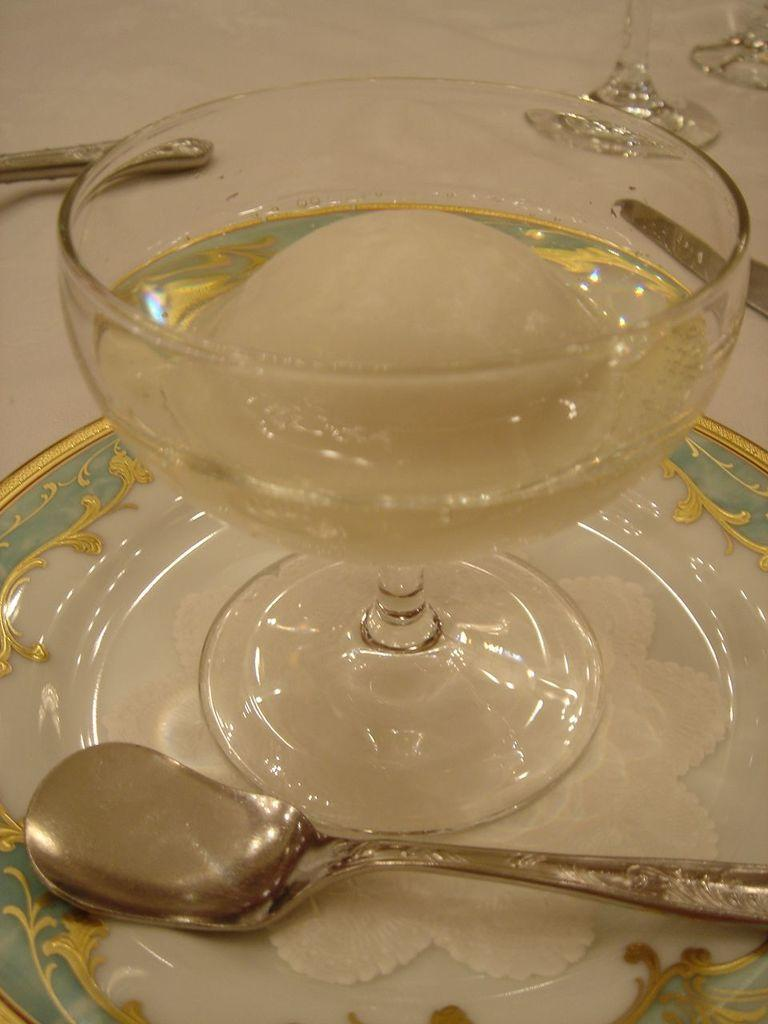What is inside the glass that is visible in the image? There is ice in a glass in the image. What is the glass placed on in the image? The glass is placed on a ceramic plate in the image. What utensil can be seen in the image? There is a spoon in the image. What is the price of the chance in the image? There is no chance or price present in the image; it features a glass with ice, a ceramic plate, and a spoon. 